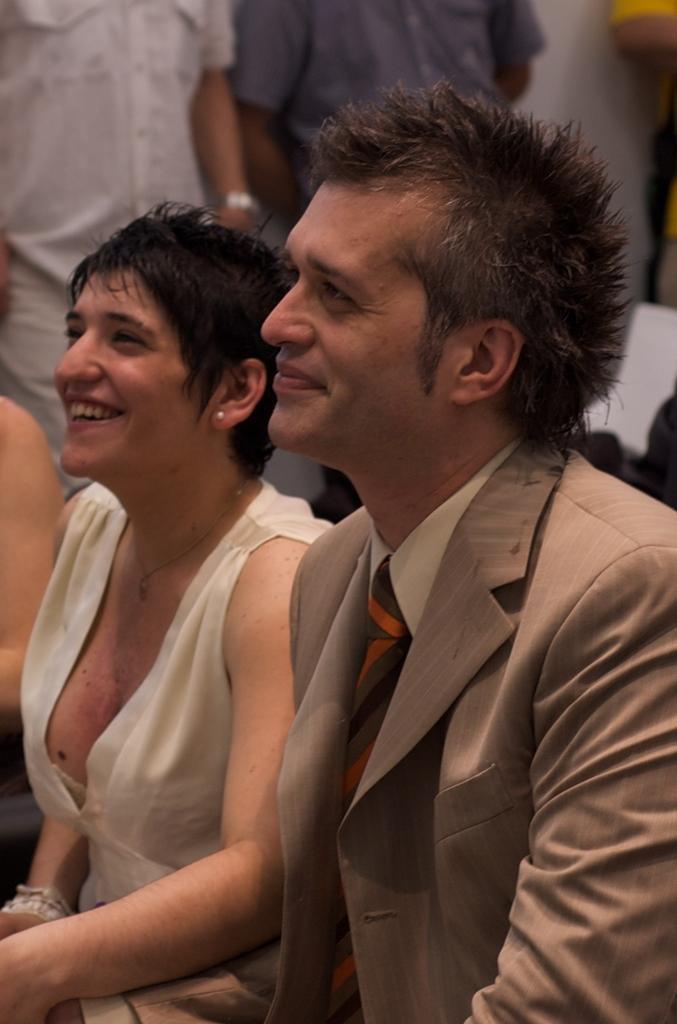Could you give a brief overview of what you see in this image? In this image, we can see a man and a woman sitting, we can see two people standing. 